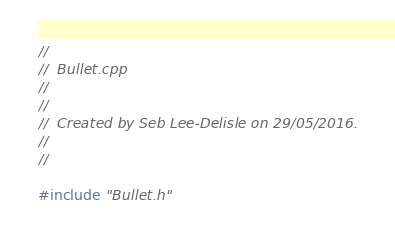Convert code to text. <code><loc_0><loc_0><loc_500><loc_500><_C++_>//
//  Bullet.cpp
//  
//
//  Created by Seb Lee-Delisle on 29/05/2016.
//
//

#include "Bullet.h"
</code> 